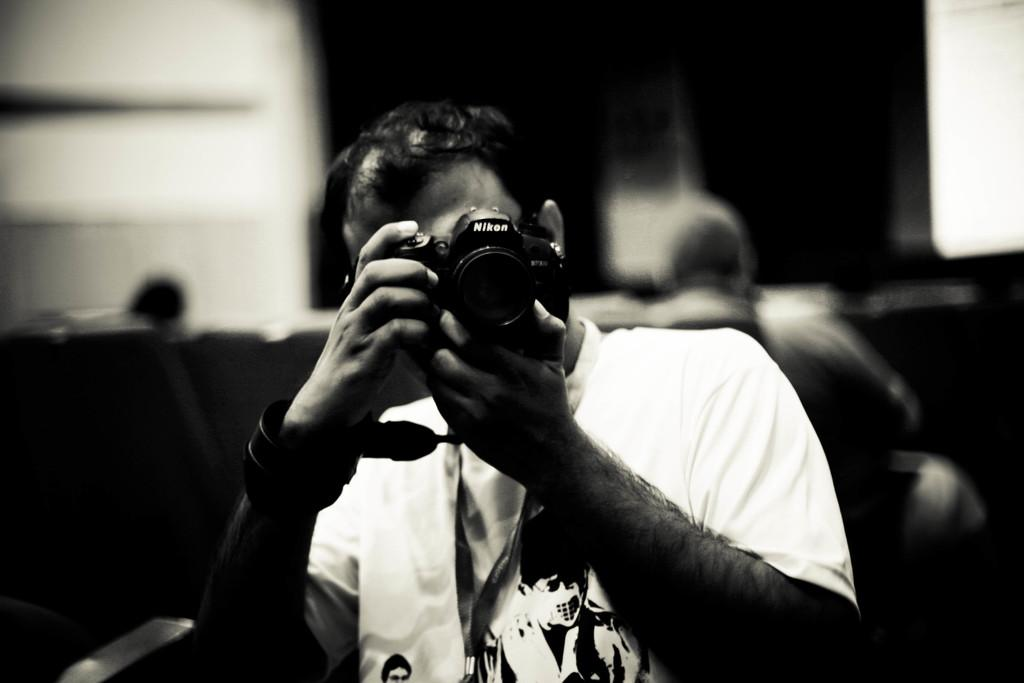Who is the main subject in the image? There is a man in the image. What is the man doing in the image? The man is standing and taking a picture. What is the man holding in his hand? The man is holding a camera in his hand. What type of structure can be seen in the background of the image? There is no structure visible in the background of the image. What does the man look like in the image? The provided facts do not describe the man's appearance, so we cannot answer this question. 